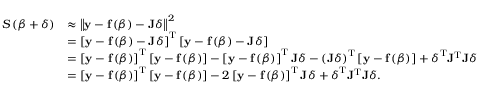<formula> <loc_0><loc_0><loc_500><loc_500>{ \begin{array} { r l } { S \left ( { \beta } + { \delta } \right ) } & { \approx \left \| y - f \left ( { \beta } \right ) - J { \delta } \right \| ^ { 2 } } \\ & { = \left [ y - f \left ( { \beta } \right ) - J { \delta } \right ] ^ { T } \left [ y - f \left ( { \beta } \right ) - J { \delta } \right ] } \\ & { = \left [ y - f \left ( { \beta } \right ) \right ] ^ { T } \left [ y - f \left ( { \beta } \right ) \right ] - \left [ y - f \left ( { \beta } \right ) \right ] ^ { T } J { \delta } - \left ( J { \delta } \right ) ^ { T } \left [ y - f \left ( { \beta } \right ) \right ] + { \delta } ^ { T } J ^ { T } J { \delta } } \\ & { = \left [ y - f \left ( { \beta } \right ) \right ] ^ { T } \left [ y - f \left ( { \beta } \right ) \right ] - 2 \left [ y - f \left ( { \beta } \right ) \right ] ^ { T } J { \delta } + { \delta } ^ { T } J ^ { T } J { \delta } . } \end{array} }</formula> 